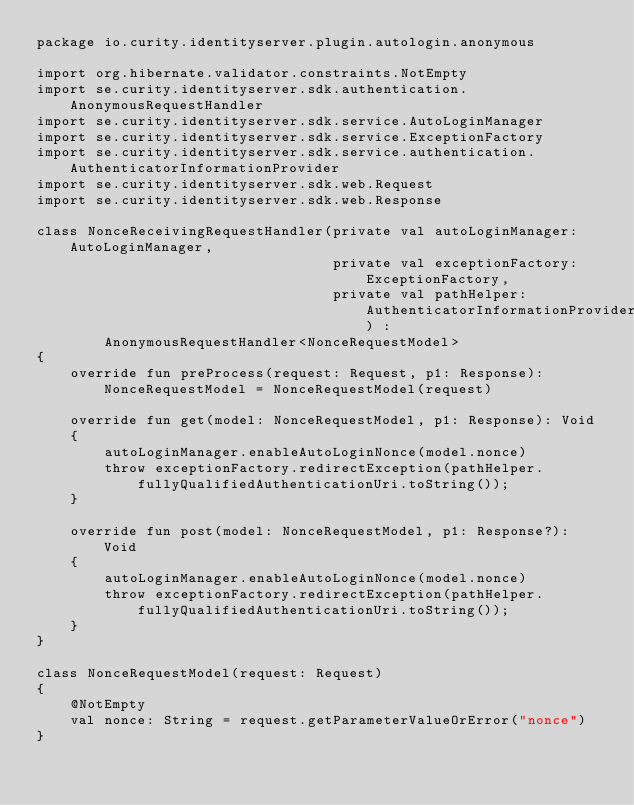Convert code to text. <code><loc_0><loc_0><loc_500><loc_500><_Kotlin_>package io.curity.identityserver.plugin.autologin.anonymous

import org.hibernate.validator.constraints.NotEmpty
import se.curity.identityserver.sdk.authentication.AnonymousRequestHandler
import se.curity.identityserver.sdk.service.AutoLoginManager
import se.curity.identityserver.sdk.service.ExceptionFactory
import se.curity.identityserver.sdk.service.authentication.AuthenticatorInformationProvider
import se.curity.identityserver.sdk.web.Request
import se.curity.identityserver.sdk.web.Response

class NonceReceivingRequestHandler(private val autoLoginManager: AutoLoginManager,
                                   private val exceptionFactory: ExceptionFactory,
                                   private val pathHelper: AuthenticatorInformationProvider) :
        AnonymousRequestHandler<NonceRequestModel>
{
    override fun preProcess(request: Request, p1: Response): NonceRequestModel = NonceRequestModel(request)

    override fun get(model: NonceRequestModel, p1: Response): Void
    {
        autoLoginManager.enableAutoLoginNonce(model.nonce)
        throw exceptionFactory.redirectException(pathHelper.fullyQualifiedAuthenticationUri.toString());
    }

    override fun post(model: NonceRequestModel, p1: Response?): Void
    {
        autoLoginManager.enableAutoLoginNonce(model.nonce)
        throw exceptionFactory.redirectException(pathHelper.fullyQualifiedAuthenticationUri.toString());
    }
}

class NonceRequestModel(request: Request)
{
    @NotEmpty
    val nonce: String = request.getParameterValueOrError("nonce")
}
</code> 